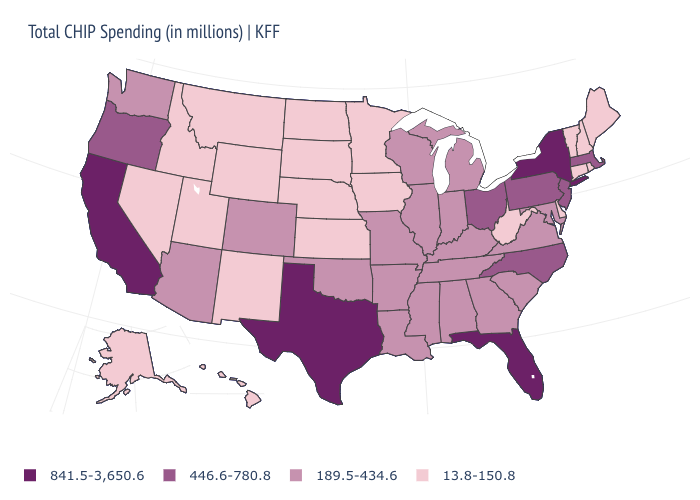What is the highest value in the USA?
Give a very brief answer. 841.5-3,650.6. What is the value of North Dakota?
Answer briefly. 13.8-150.8. What is the lowest value in the USA?
Keep it brief. 13.8-150.8. Which states have the lowest value in the USA?
Be succinct. Alaska, Connecticut, Delaware, Hawaii, Idaho, Iowa, Kansas, Maine, Minnesota, Montana, Nebraska, Nevada, New Hampshire, New Mexico, North Dakota, Rhode Island, South Dakota, Utah, Vermont, West Virginia, Wyoming. Name the states that have a value in the range 13.8-150.8?
Write a very short answer. Alaska, Connecticut, Delaware, Hawaii, Idaho, Iowa, Kansas, Maine, Minnesota, Montana, Nebraska, Nevada, New Hampshire, New Mexico, North Dakota, Rhode Island, South Dakota, Utah, Vermont, West Virginia, Wyoming. What is the value of Ohio?
Be succinct. 446.6-780.8. Name the states that have a value in the range 189.5-434.6?
Write a very short answer. Alabama, Arizona, Arkansas, Colorado, Georgia, Illinois, Indiana, Kentucky, Louisiana, Maryland, Michigan, Mississippi, Missouri, Oklahoma, South Carolina, Tennessee, Virginia, Washington, Wisconsin. What is the highest value in the MidWest ?
Write a very short answer. 446.6-780.8. What is the value of Vermont?
Quick response, please. 13.8-150.8. What is the value of Connecticut?
Short answer required. 13.8-150.8. What is the lowest value in the West?
Write a very short answer. 13.8-150.8. Does the map have missing data?
Quick response, please. No. What is the value of Nevada?
Write a very short answer. 13.8-150.8. What is the lowest value in the West?
Give a very brief answer. 13.8-150.8. What is the lowest value in states that border Indiana?
Quick response, please. 189.5-434.6. 